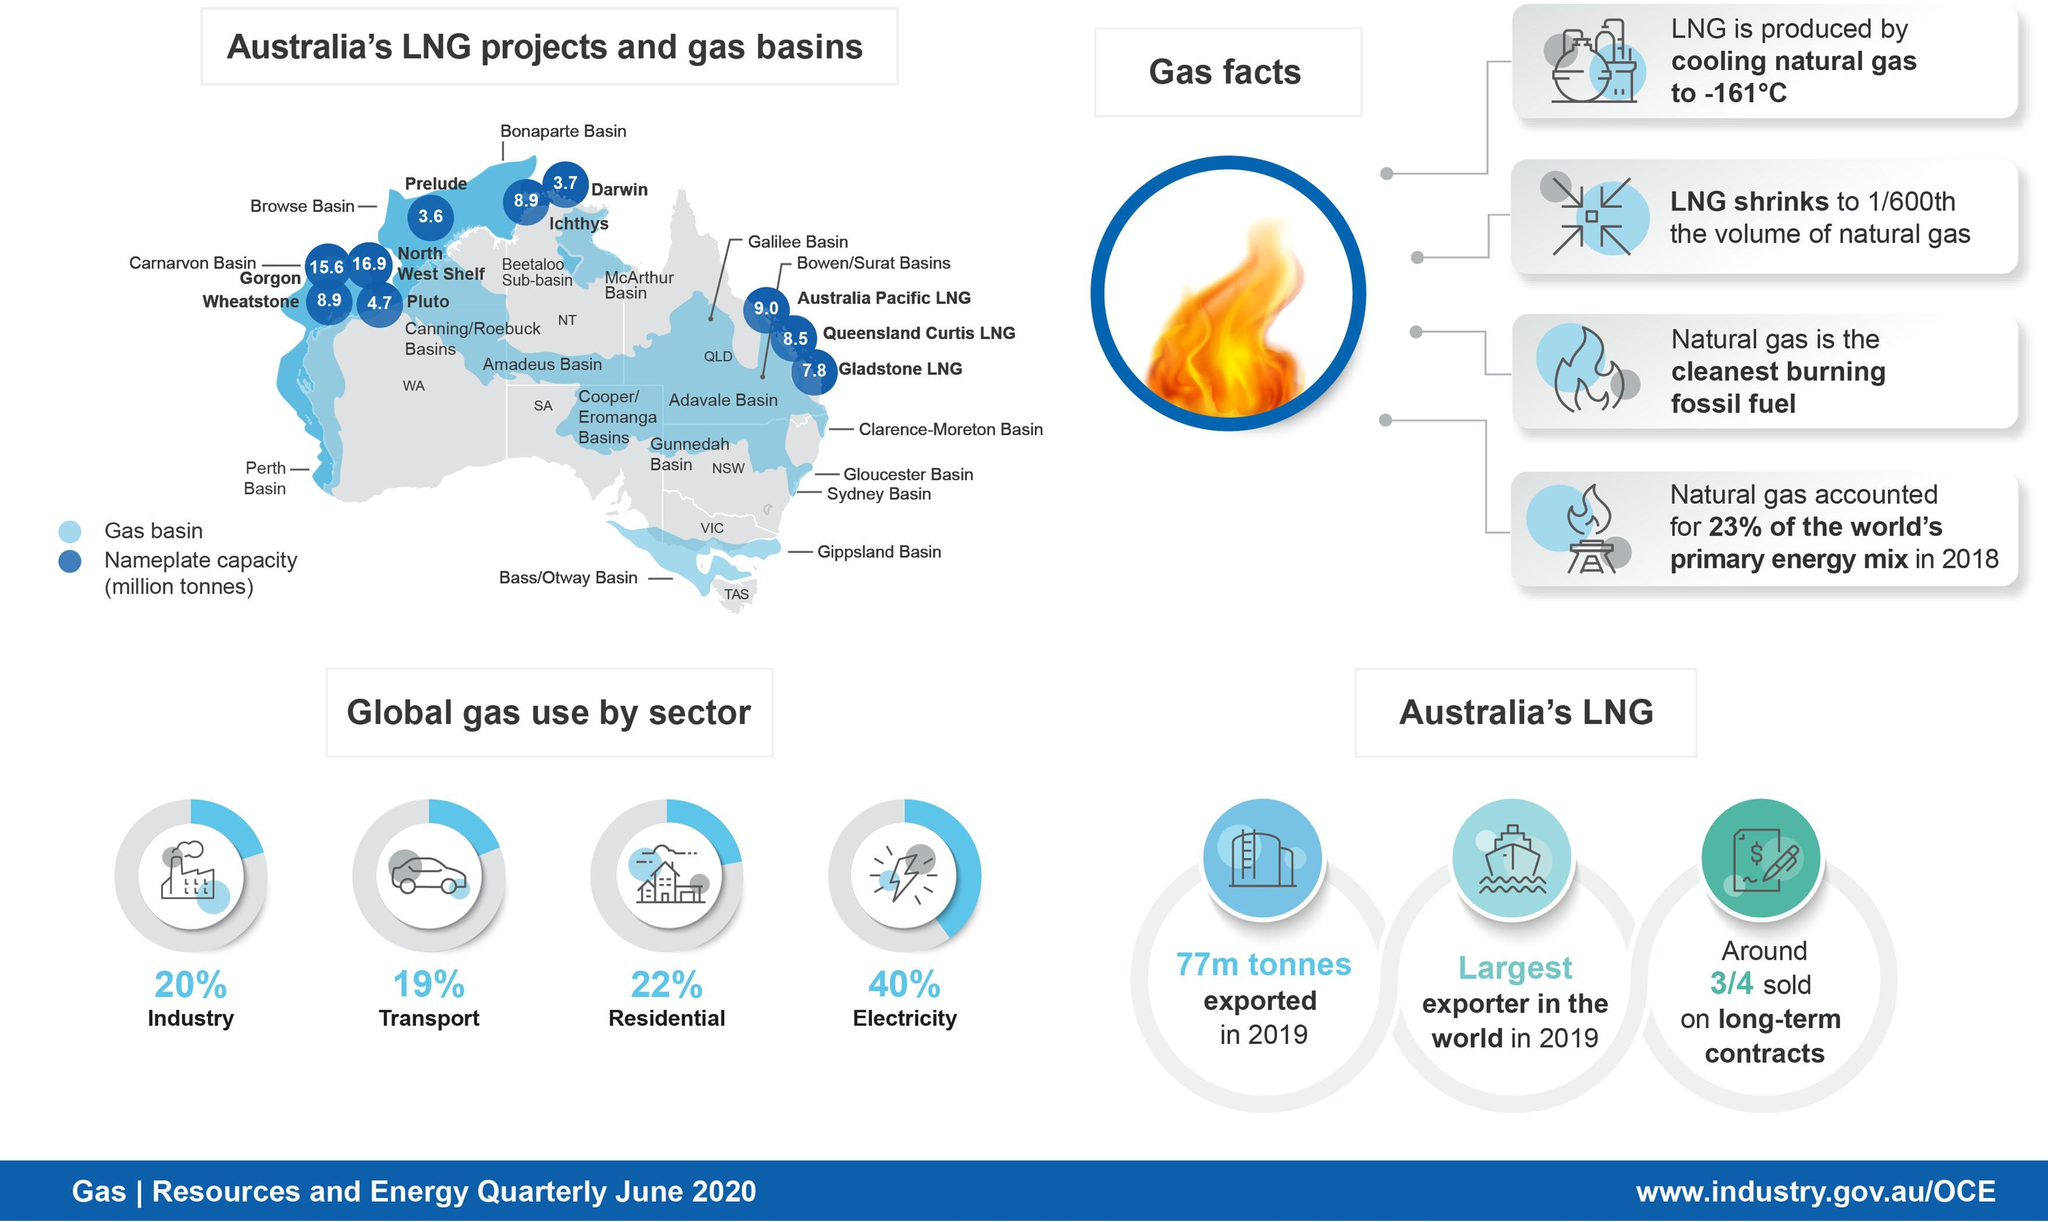What quantity of LNG was exported by Australia in 2019?
Answer the question with a short phrase. 77m tonnes How many million tonnes of LNG is produced per annum by the Gorgon LNG project? 15.6 What is the percentage use of the natural gas in the industrial sector globally? 20% What percent of the world's primary energy mix was contributed by the natural gas in 2018? 23% How many million tonnes of LNG is produced per annum by the Wheatstone LNG project? 8.9 What is the percentage use of the natural gas in the residential sector globally? 22% How many million tonnes of LNG is produced per annum by the Australia Pacific LNG project? 9.0 